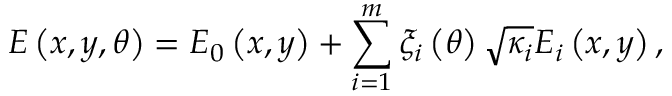<formula> <loc_0><loc_0><loc_500><loc_500>E \left ( x , y , \theta \right ) = E _ { 0 } \left ( x , y \right ) + \sum _ { i = 1 } ^ { m } \xi _ { i } \left ( \theta \right ) \sqrt { \kappa _ { i } } E _ { i } \left ( x , y \right ) ,</formula> 